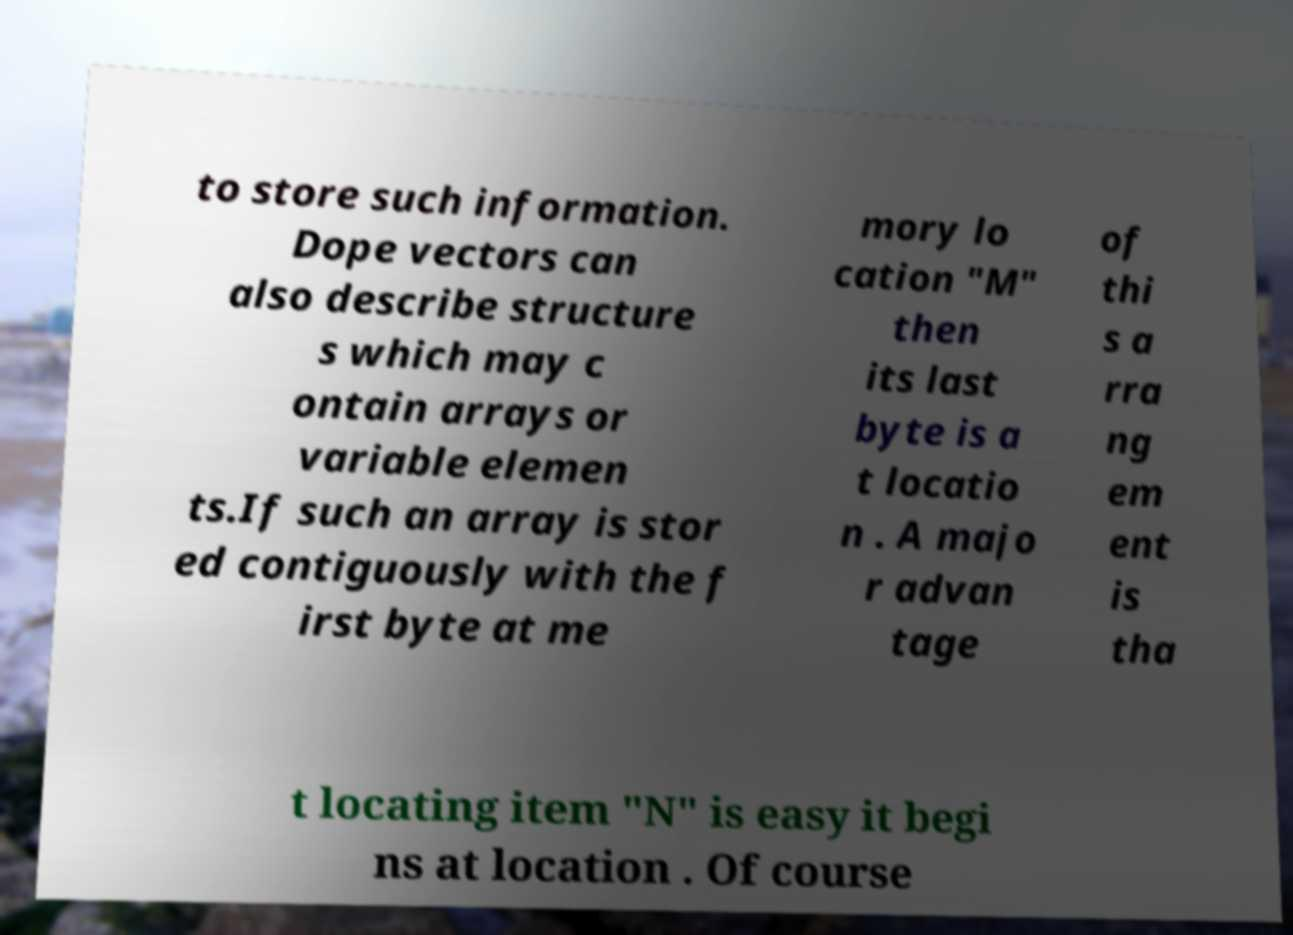Can you accurately transcribe the text from the provided image for me? to store such information. Dope vectors can also describe structure s which may c ontain arrays or variable elemen ts.If such an array is stor ed contiguously with the f irst byte at me mory lo cation "M" then its last byte is a t locatio n . A majo r advan tage of thi s a rra ng em ent is tha t locating item "N" is easy it begi ns at location . Of course 